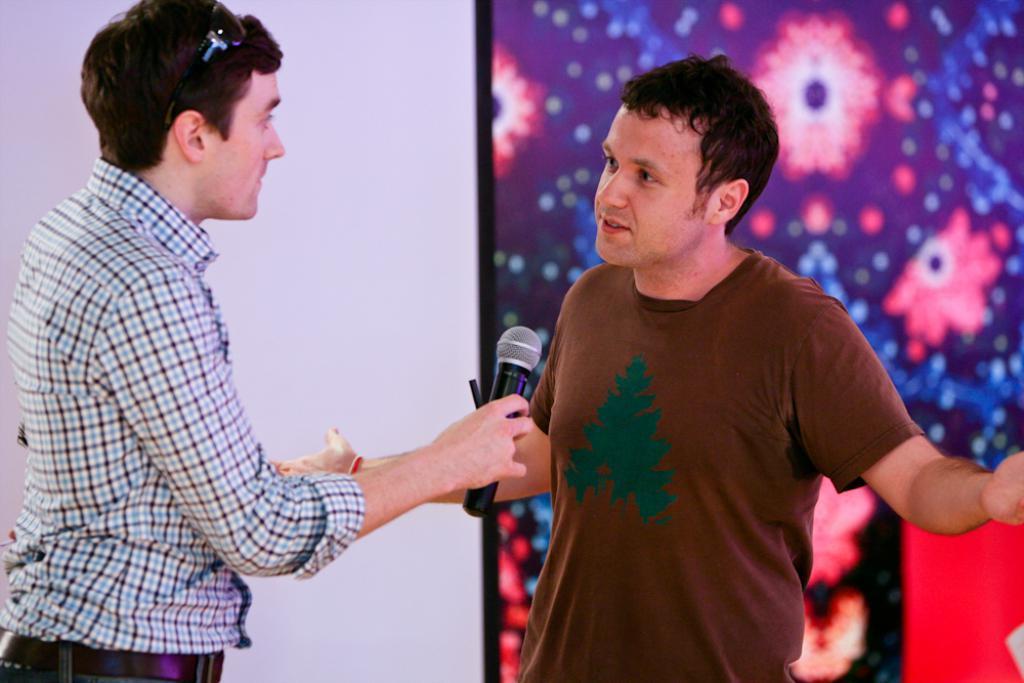Can you describe this image briefly? This image consists of two persons. One is holding mic and wearing goggles. 